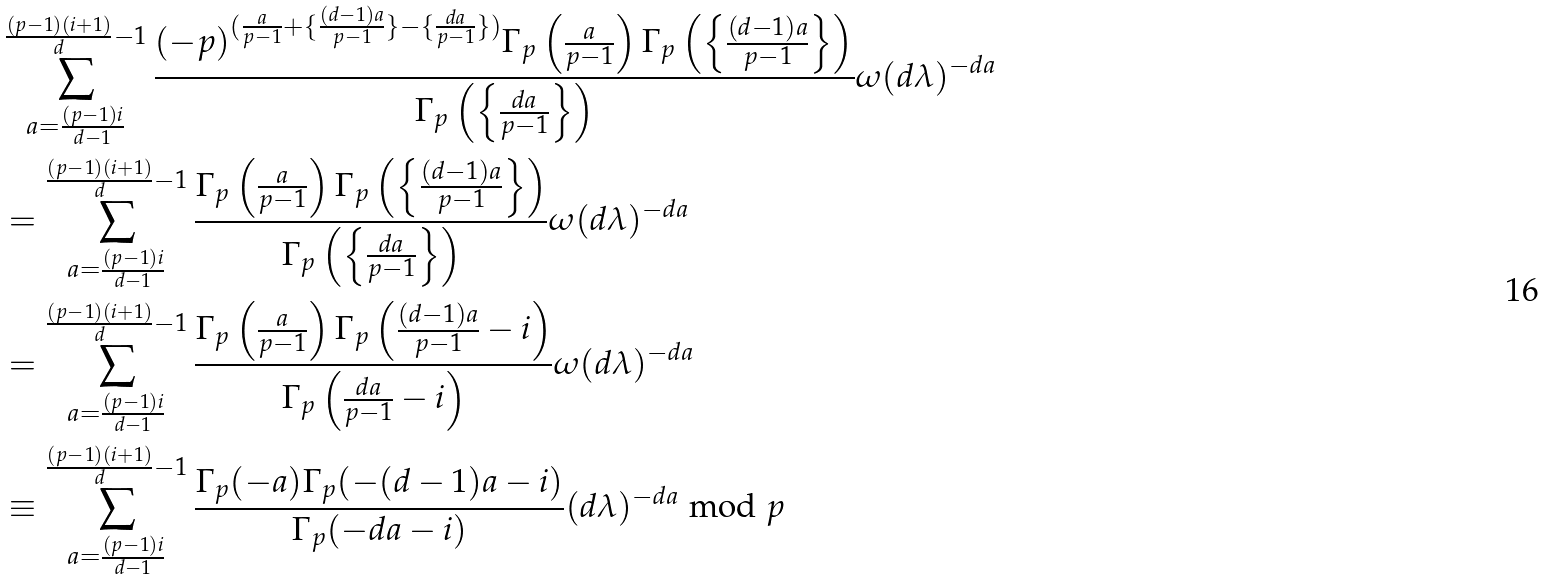Convert formula to latex. <formula><loc_0><loc_0><loc_500><loc_500>& \sum _ { a = \frac { ( p - 1 ) i } { d - 1 } } ^ { \frac { ( p - 1 ) ( i + 1 ) } { d } - 1 } \frac { ( - p ) ^ { ( \frac { a } { p - 1 } + \{ \frac { ( d - 1 ) a } { p - 1 } \} - \{ \frac { d a } { p - 1 } \} ) } \Gamma _ { p } \left ( \frac { a } { p - 1 } \right ) \Gamma _ { p } \left ( \left \{ \frac { ( d - 1 ) a } { p - 1 } \right \} \right ) } { \Gamma _ { p } \left ( \left \{ \frac { d a } { p - 1 } \right \} \right ) } \omega ( d \lambda ) ^ { - d a } \\ & = \sum _ { a = \frac { ( p - 1 ) i } { d - 1 } } ^ { \frac { ( p - 1 ) ( i + 1 ) } { d } - 1 } \frac { \Gamma _ { p } \left ( \frac { a } { p - 1 } \right ) \Gamma _ { p } \left ( \left \{ \frac { ( d - 1 ) a } { p - 1 } \right \} \right ) } { \Gamma _ { p } \left ( \left \{ \frac { d a } { p - 1 } \right \} \right ) } \omega ( d \lambda ) ^ { - d a } \\ & = \sum _ { a = \frac { ( p - 1 ) i } { d - 1 } } ^ { \frac { ( p - 1 ) ( i + 1 ) } { d } - 1 } \frac { \Gamma _ { p } \left ( \frac { a } { p - 1 } \right ) \Gamma _ { p } \left ( \frac { ( d - 1 ) a } { p - 1 } - i \right ) } { \Gamma _ { p } \left ( \frac { d a } { p - 1 } - i \right ) } \omega ( d \lambda ) ^ { - d a } \\ & \equiv \sum _ { a = \frac { ( p - 1 ) i } { d - 1 } } ^ { \frac { ( p - 1 ) ( i + 1 ) } { d } - 1 } \frac { \Gamma _ { p } ( - a ) \Gamma _ { p } ( - ( d - 1 ) a - i ) } { \Gamma _ { p } ( - d a - i ) } ( d \lambda ) ^ { - d a } \bmod p \\</formula> 